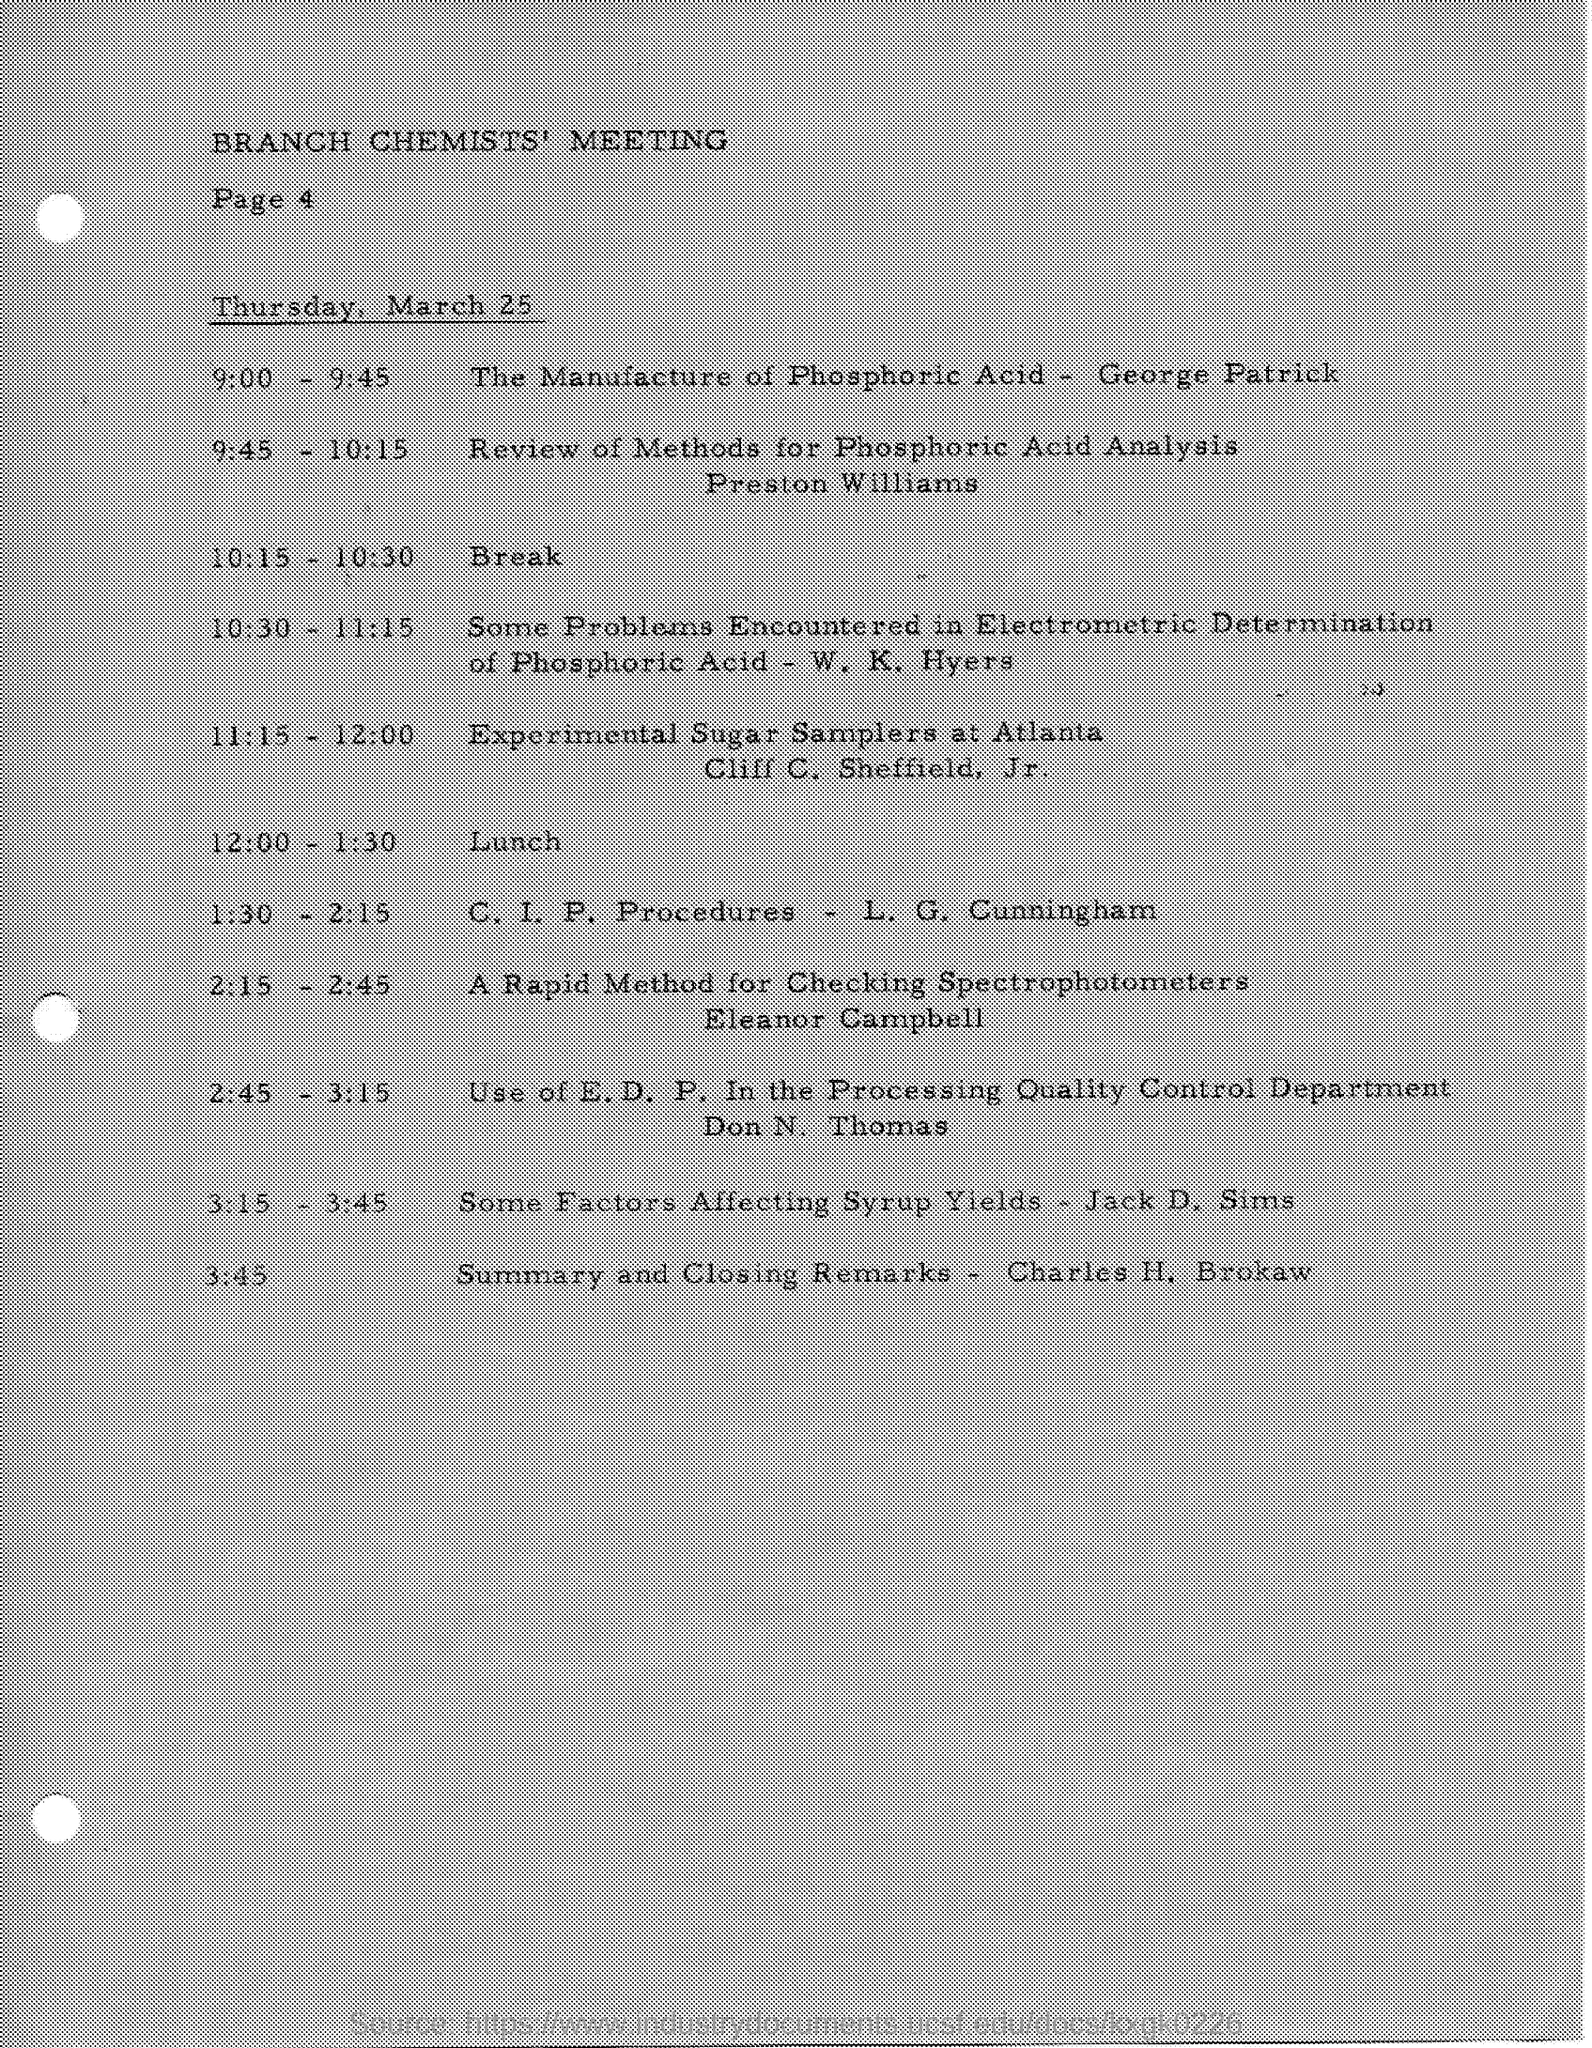Who discussed about Review methods for Phosphoric Acid Analysis? The review of methods for phosphoric acid analysis was discussed by Preston Williams during the Branch Chemists' Meeting as noted in the schedule. This session likely covered advancements and techniques in the analytical approaches to phosphoric acid, crucial for ensuring quality and efficiency in chemical manufacturing. 